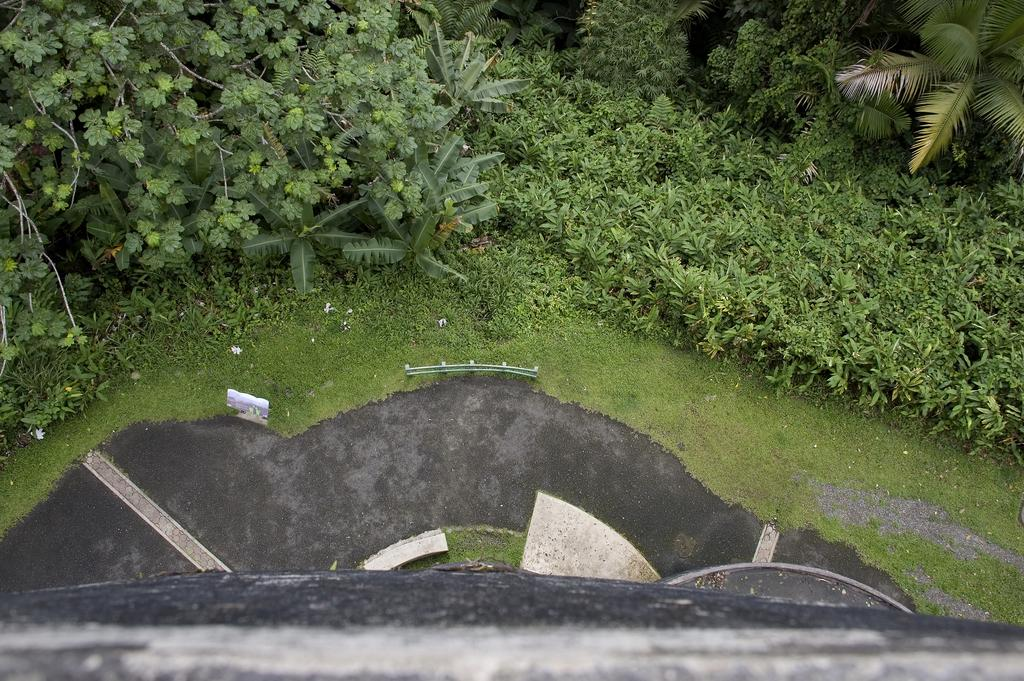What type of vegetation is present in the image? There are plants, trees, and grass in the image. What type of surface can be seen in the image? There is a road and land in the image. What other objects can be seen in the image? There are stones and a wall at the bottom of the image. What type of mountain is visible on the page in the image? There is no mountain or page present in the image; it features plants, trees, grass, a road, land, stones, and a wall. How are the plants being transported in the image? The plants are not being transported in the image; they are stationary in the ground. 